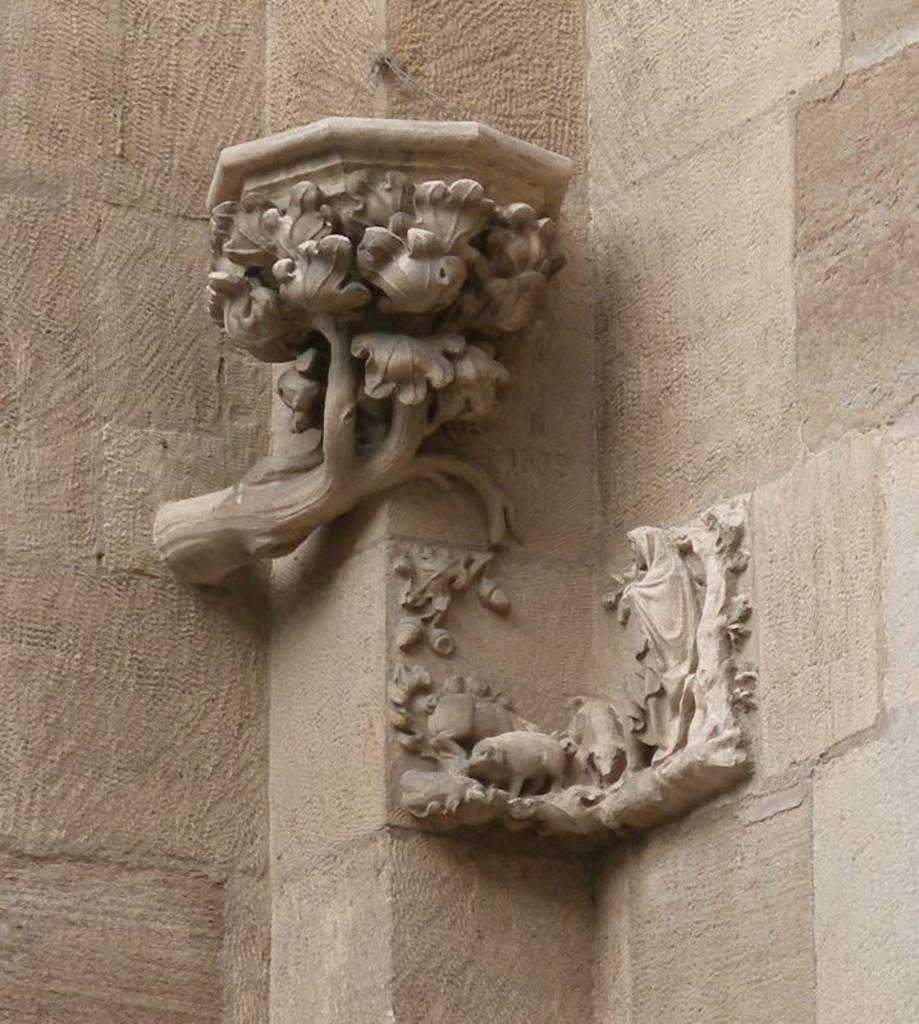What is present on the wall in the image? The wall has sculptures on it. Can you describe the sculptures on the wall? Unfortunately, the provided facts do not include a description of the sculptures. What is the primary purpose of the wall in the image? The primary purpose of the wall cannot be determined from the provided facts. What type of agreement was reached by the secretary and the quince in the image? There is no secretary or quince present in the image, so no such agreement can be observed. 